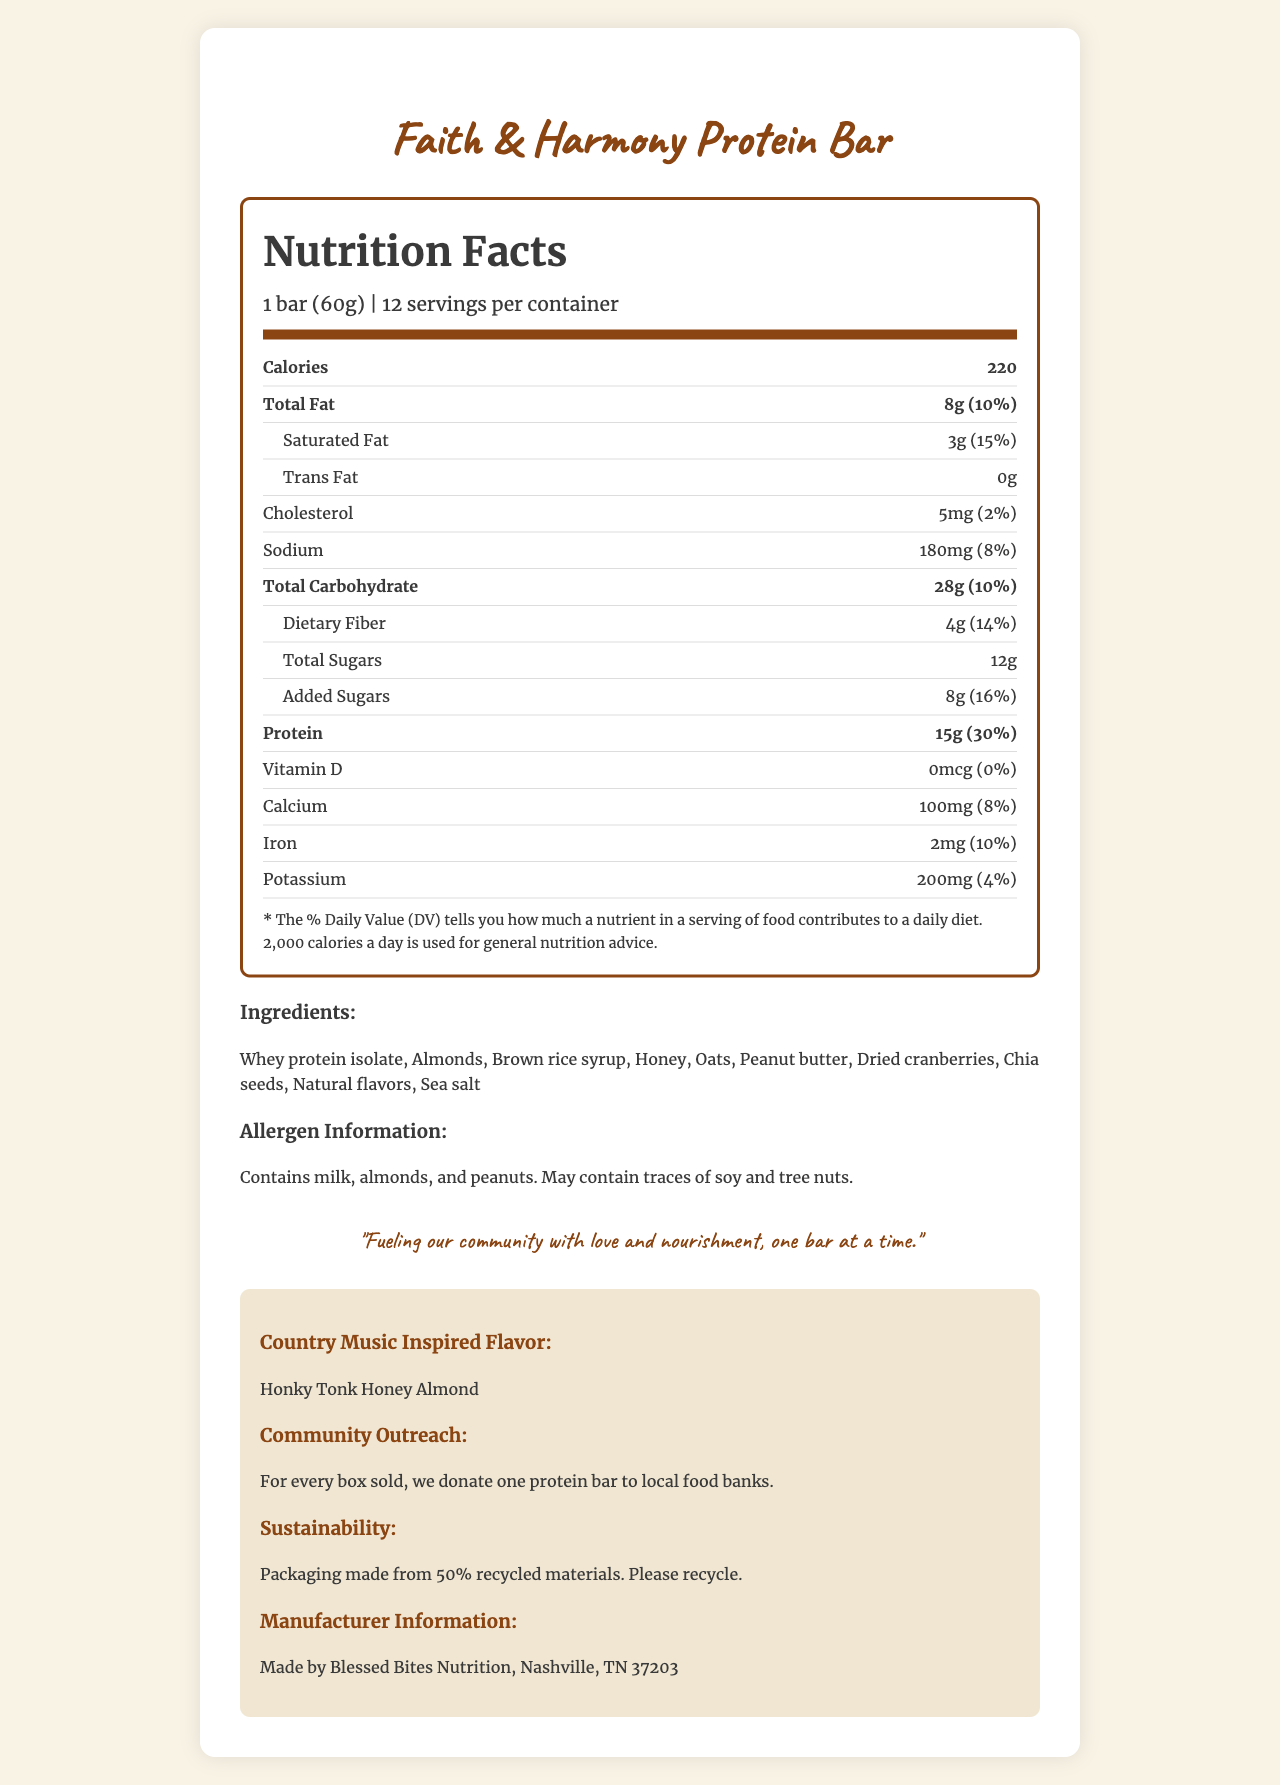what is the serving size of the Faith & Harmony Protein Bar? The serving size mentioned right under the product name in the document is 1 bar, weighing 60 grams.
Answer: 1 bar (60g) how many calories are there per serving? The document states in the nutrition facts section that each serving contains 220 calories.
Answer: 220 calories what percentage of the Daily Value of protein does one bar provide? According to the nutrition facts, the protein content per serving is 15g, which is 30% of the Daily Value.
Answer: 30% how much saturated fat is in one bar? The nutrition label lists the saturated fat content as 3 grams per serving.
Answer: 3g what is the special flavor of this protein bar? The additional information section mentions that the flavor is inspired by country music and is named "Honky Tonk Honey Almond".
Answer: Honky Tonk Honey Almond how much dietary fiber is in one serving? The nutrition facts indicate that there are 4 grams of dietary fiber in one serving.
Answer: 4g how many ingredients are listed in the ingredient section? There are ten ingredients listed in the ingredients section.
Answer: 10 ingredients In which city is the manufacturer of the Faith & Harmony Protein Bar located? The document states that the manufacturer, Blessed Bites Nutrition, is located in Nashville, TN 37203.
Answer: Nashville, TN how many protein bars does each container have? The document lists that there are 12 servings per container.
Answer: 12 servings what is the mission statement of Faith & Harmony Protein Bar? The mission statement is clearly stated in a designated quote section and reads, "Fueling our community with love and nourishment, one bar at a time."
Answer: Fueling our community with love and nourishment, one bar at a time. does this bar contain any added sugars? The nutrition facts mention that there are 8 grams of added sugars per serving.
Answer: Yes how much sodium is in one bar? The nutrition facts section lists the sodium content as 180 milligrams per serving.
Answer: 180mg how much cholesterol does one bar contain? A. 0mg B. 5mg C. 10mg D. 15mg The nutrition label indicates that there is 5 milligrams of cholesterol per serving.
Answer: B. 5mg which element is not present in this protein bar: Vitamin D, Calcium, Iron, or Potassium? The nutrition facts indicate that the Vitamin D content is 0 mcg, suggesting it is not present in the bar.
Answer: Vitamin D which of these fats is present in the Faith & Harmony Protein Bar? i. Monounsaturated fat ii. Polyunsaturated fat iii. Trans fat iv. Saturated fat The document explicitly lists the amount of saturated fat present, while trans fat is 0 grams, and there is no mention of monounsaturated or polyunsaturated fats.
Answer: iv. Saturated fat does the nutrition label mention the percentage of daily value for potassium? The document mentions that the potassium amount is 200mg, which is 4% of the daily value.
Answer: Yes how much iron is in one serving? The iron content per serving is listed as 2 milligrams in the nutrition facts section.
Answer: 2mg how many different allergens are mentioned in the allergen information section? The allergen info mentions milk, almonds, peanuts, and possible traces of soy and tree nuts.
Answer: Four what is the purpose of the community outreach program related to this product? The community outreach information states that one protein bar is donated to local food banks for every box sold.
Answer: Donating one protein bar to local food banks for every box sold. what is the main purpose of the document? The document focuses on offering comprehensive details about the nutritional value and ingredients of the protein bar, along with its community and sustainability initiatives.
Answer: To provide detailed nutritional information, ingredients, allergen warnings, manufacturer details, and mission-related initiatives of the Faith & Harmony Protein Bar. what is the country of origin of the whey protein isolate used in the bar? The document does not provide any information regarding the country of origin of the whey protein isolate.
Answer: Cannot be determined 